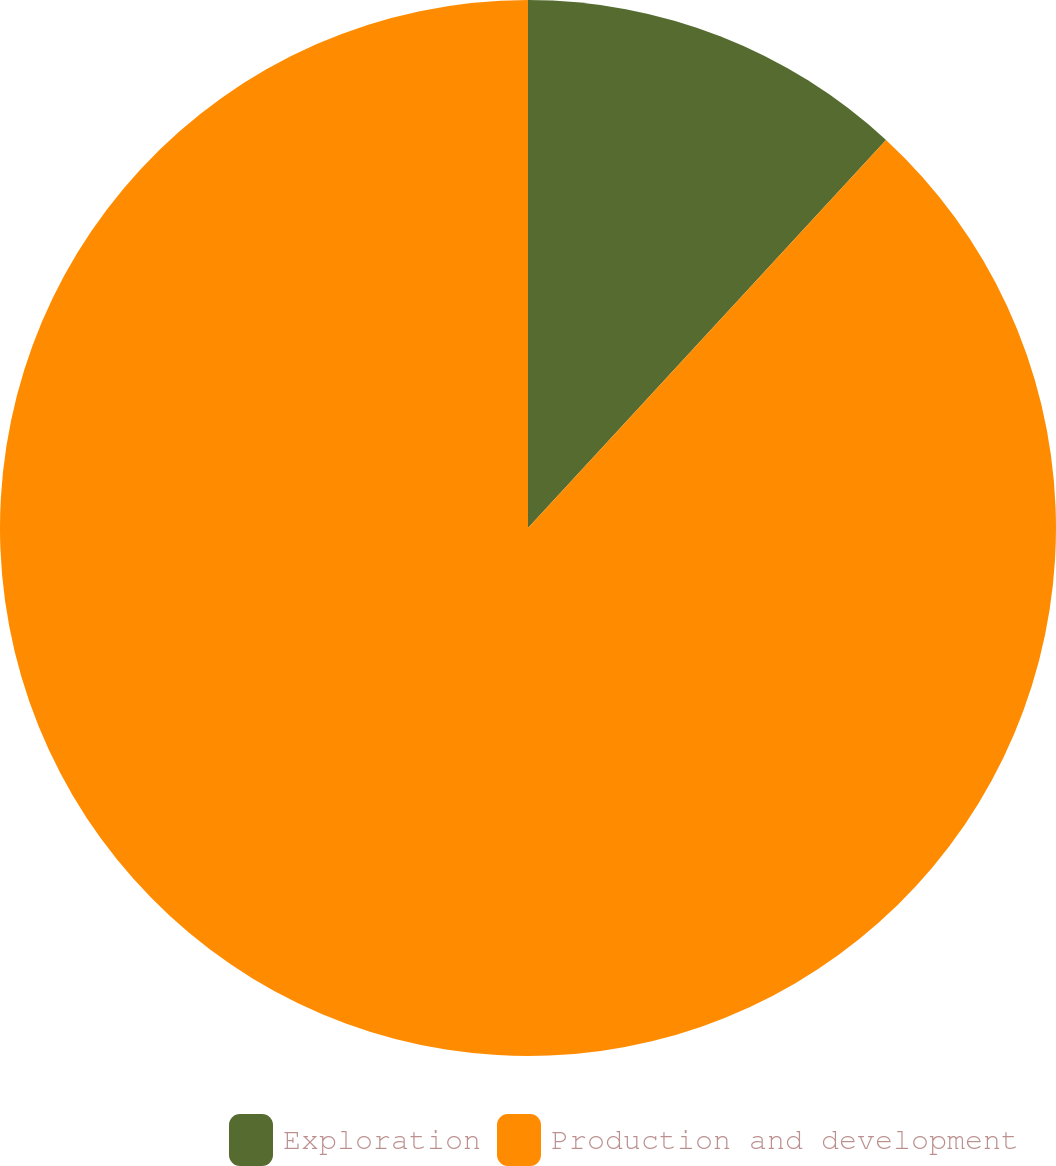Convert chart. <chart><loc_0><loc_0><loc_500><loc_500><pie_chart><fcel>Exploration<fcel>Production and development<nl><fcel>11.86%<fcel>88.14%<nl></chart> 